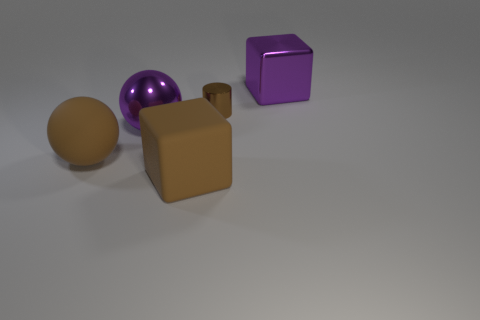Add 2 rubber cylinders. How many objects exist? 7 Subtract 1 cubes. How many cubes are left? 1 Subtract all cubes. How many objects are left? 3 Add 4 big brown rubber things. How many big brown rubber things exist? 6 Subtract 1 purple balls. How many objects are left? 4 Subtract all yellow cubes. Subtract all yellow cylinders. How many cubes are left? 2 Subtract all green metal spheres. Subtract all rubber cubes. How many objects are left? 4 Add 1 big balls. How many big balls are left? 3 